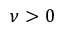<formula> <loc_0><loc_0><loc_500><loc_500>\nu > 0</formula> 